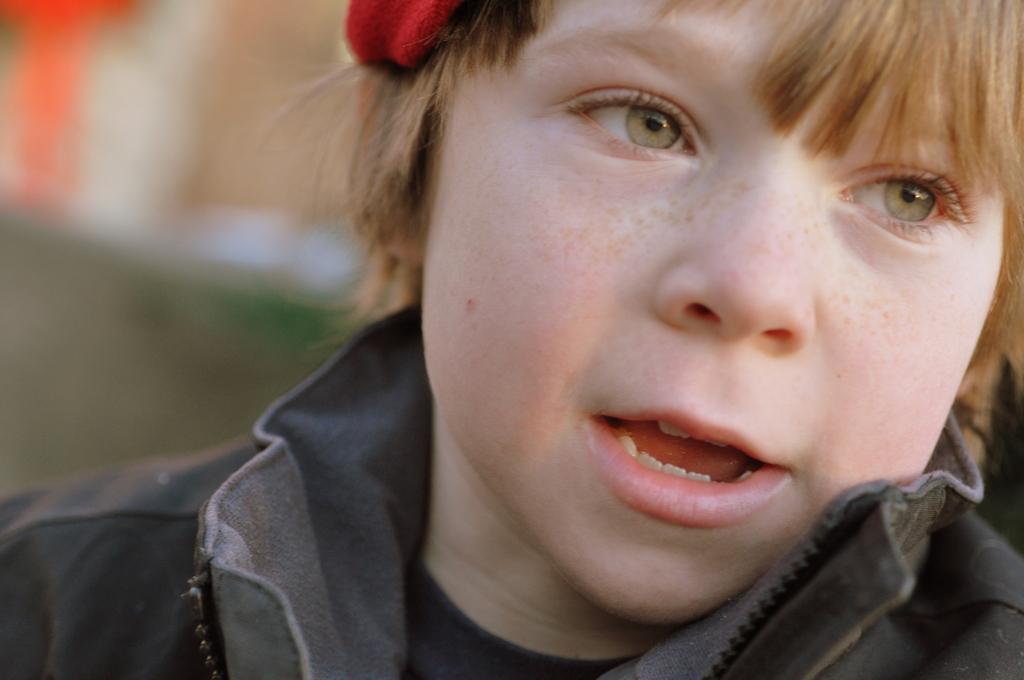Could you give a brief overview of what you see in this image? In this image I can see a boy and I can see he is wearing black colour dress. I can also see red colour thing over here and I can see this image is blurry from background. 